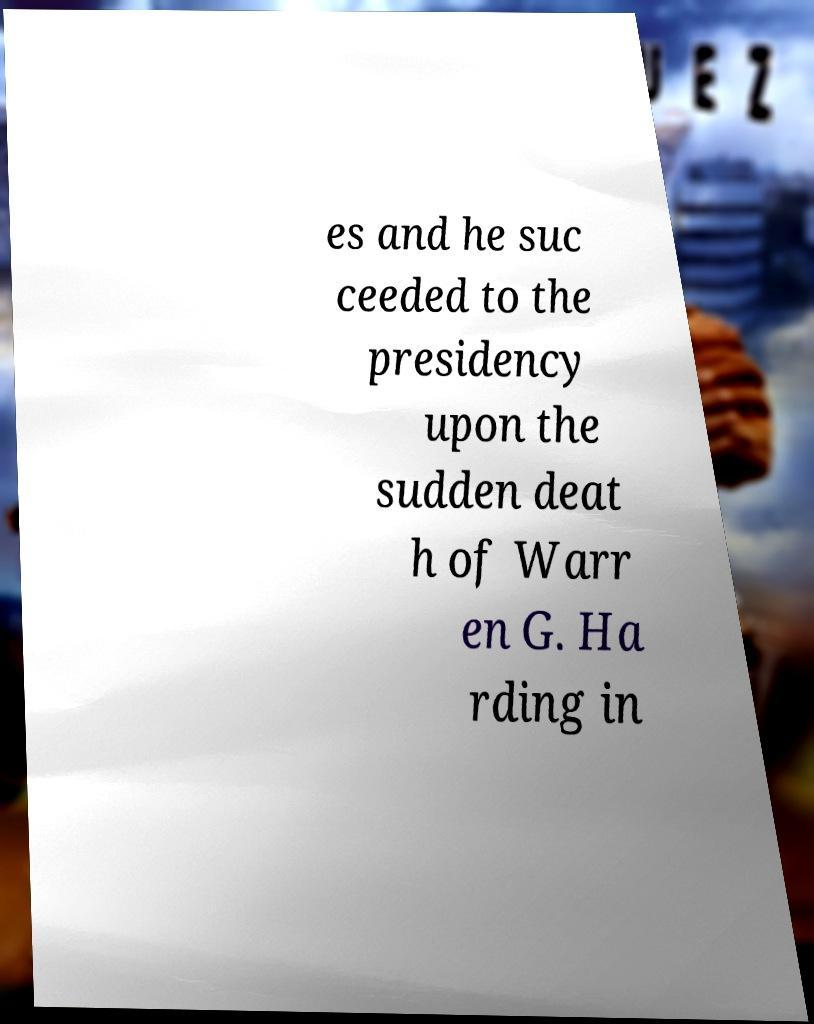What messages or text are displayed in this image? I need them in a readable, typed format. es and he suc ceeded to the presidency upon the sudden deat h of Warr en G. Ha rding in 